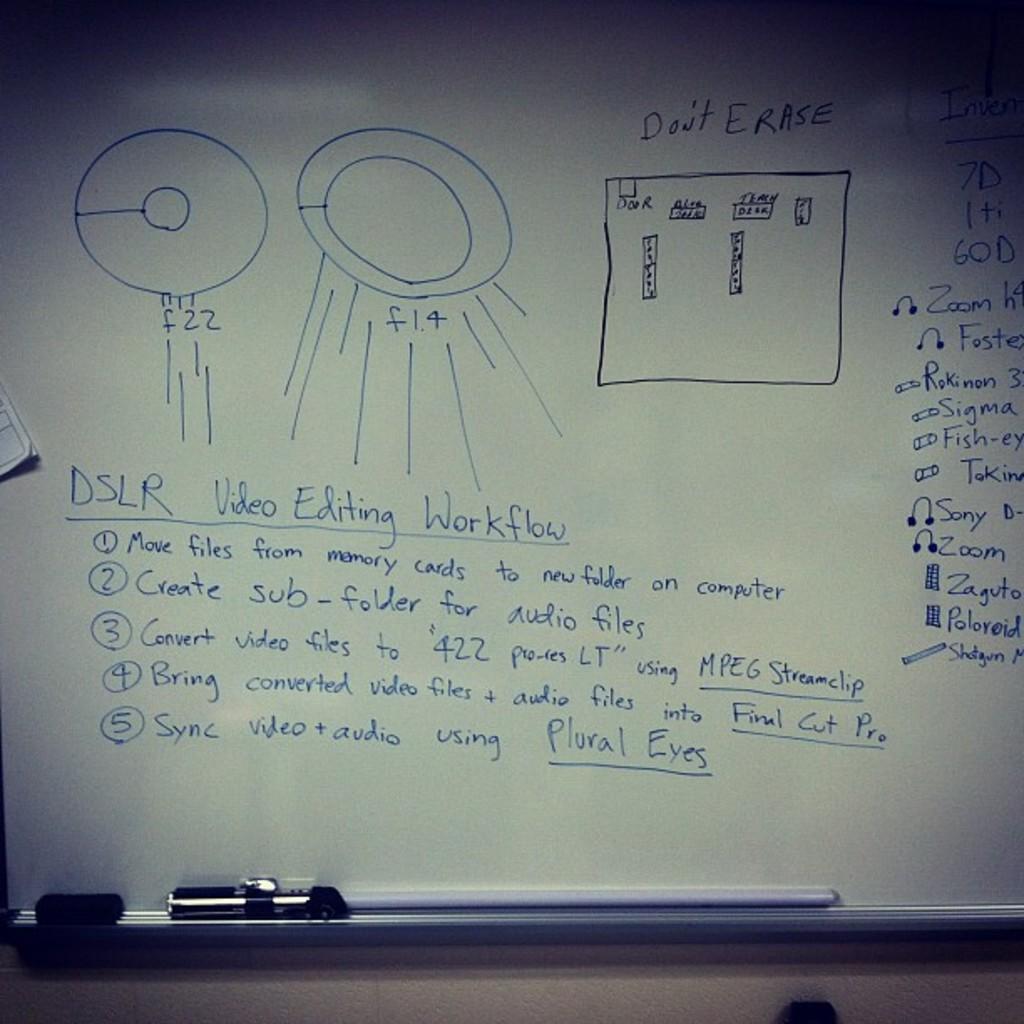Should the white board be erased?
Your answer should be very brief. No. 